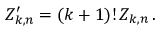<formula> <loc_0><loc_0><loc_500><loc_500>Z _ { k , n } ^ { \prime } = ( k + 1 ) ! \, Z _ { k , n } \, .</formula> 